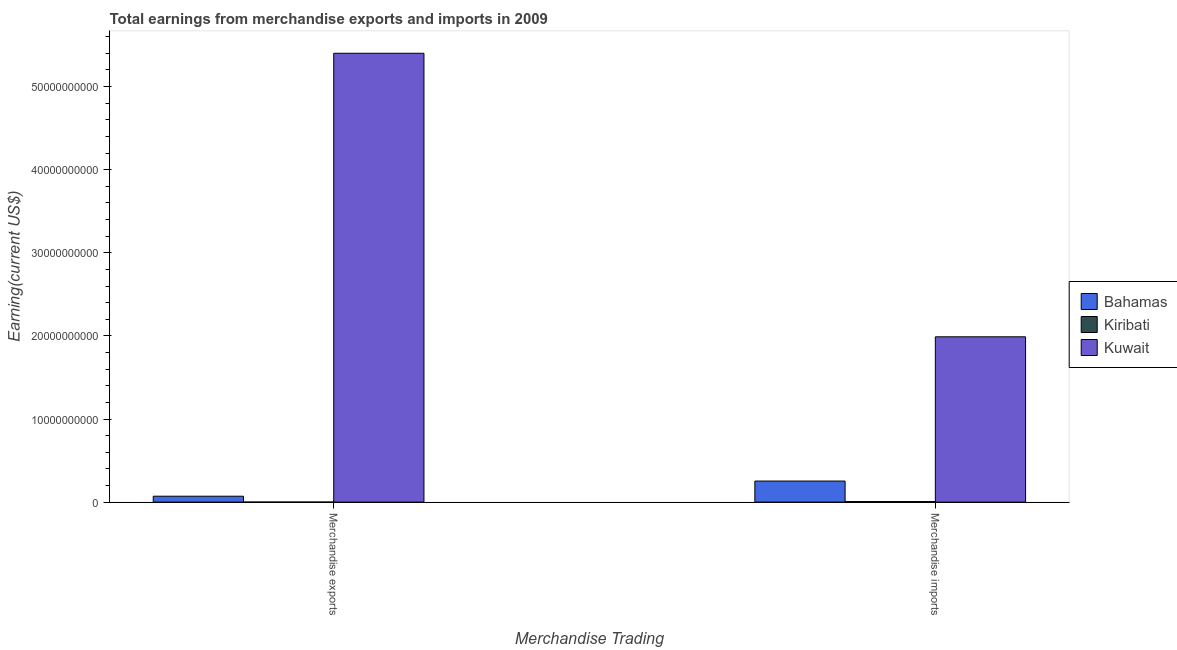How many groups of bars are there?
Give a very brief answer. 2. Are the number of bars on each tick of the X-axis equal?
Offer a terse response. Yes. How many bars are there on the 1st tick from the left?
Make the answer very short. 3. What is the earnings from merchandise exports in Kiribati?
Your answer should be compact. 6.28e+06. Across all countries, what is the maximum earnings from merchandise exports?
Offer a very short reply. 5.40e+1. Across all countries, what is the minimum earnings from merchandise exports?
Offer a terse response. 6.28e+06. In which country was the earnings from merchandise imports maximum?
Your answer should be compact. Kuwait. In which country was the earnings from merchandise exports minimum?
Keep it short and to the point. Kiribati. What is the total earnings from merchandise imports in the graph?
Your answer should be very brief. 2.25e+1. What is the difference between the earnings from merchandise exports in Kiribati and that in Kuwait?
Offer a very short reply. -5.40e+1. What is the difference between the earnings from merchandise imports in Kuwait and the earnings from merchandise exports in Bahamas?
Give a very brief answer. 1.92e+1. What is the average earnings from merchandise imports per country?
Give a very brief answer. 7.50e+09. What is the difference between the earnings from merchandise imports and earnings from merchandise exports in Bahamas?
Make the answer very short. 1.82e+09. What is the ratio of the earnings from merchandise imports in Kuwait to that in Kiribati?
Provide a short and direct response. 296.87. What does the 2nd bar from the left in Merchandise imports represents?
Ensure brevity in your answer.  Kiribati. What does the 3rd bar from the right in Merchandise exports represents?
Offer a very short reply. Bahamas. How many countries are there in the graph?
Your response must be concise. 3. Are the values on the major ticks of Y-axis written in scientific E-notation?
Give a very brief answer. No. Does the graph contain any zero values?
Provide a succinct answer. No. Does the graph contain grids?
Offer a terse response. No. How are the legend labels stacked?
Keep it short and to the point. Vertical. What is the title of the graph?
Make the answer very short. Total earnings from merchandise exports and imports in 2009. What is the label or title of the X-axis?
Your answer should be very brief. Merchandise Trading. What is the label or title of the Y-axis?
Make the answer very short. Earning(current US$). What is the Earning(current US$) in Bahamas in Merchandise exports?
Ensure brevity in your answer.  7.11e+08. What is the Earning(current US$) of Kiribati in Merchandise exports?
Provide a short and direct response. 6.28e+06. What is the Earning(current US$) in Kuwait in Merchandise exports?
Your answer should be compact. 5.40e+1. What is the Earning(current US$) in Bahamas in Merchandise imports?
Your response must be concise. 2.54e+09. What is the Earning(current US$) of Kiribati in Merchandise imports?
Your answer should be compact. 6.70e+07. What is the Earning(current US$) in Kuwait in Merchandise imports?
Make the answer very short. 1.99e+1. Across all Merchandise Trading, what is the maximum Earning(current US$) of Bahamas?
Make the answer very short. 2.54e+09. Across all Merchandise Trading, what is the maximum Earning(current US$) of Kiribati?
Provide a succinct answer. 6.70e+07. Across all Merchandise Trading, what is the maximum Earning(current US$) of Kuwait?
Your answer should be very brief. 5.40e+1. Across all Merchandise Trading, what is the minimum Earning(current US$) of Bahamas?
Your answer should be compact. 7.11e+08. Across all Merchandise Trading, what is the minimum Earning(current US$) in Kiribati?
Your response must be concise. 6.28e+06. Across all Merchandise Trading, what is the minimum Earning(current US$) in Kuwait?
Provide a short and direct response. 1.99e+1. What is the total Earning(current US$) of Bahamas in the graph?
Your answer should be very brief. 3.25e+09. What is the total Earning(current US$) in Kiribati in the graph?
Ensure brevity in your answer.  7.33e+07. What is the total Earning(current US$) of Kuwait in the graph?
Offer a very short reply. 7.39e+1. What is the difference between the Earning(current US$) in Bahamas in Merchandise exports and that in Merchandise imports?
Ensure brevity in your answer.  -1.82e+09. What is the difference between the Earning(current US$) of Kiribati in Merchandise exports and that in Merchandise imports?
Your answer should be compact. -6.07e+07. What is the difference between the Earning(current US$) in Kuwait in Merchandise exports and that in Merchandise imports?
Your answer should be compact. 3.41e+1. What is the difference between the Earning(current US$) in Bahamas in Merchandise exports and the Earning(current US$) in Kiribati in Merchandise imports?
Provide a short and direct response. 6.44e+08. What is the difference between the Earning(current US$) of Bahamas in Merchandise exports and the Earning(current US$) of Kuwait in Merchandise imports?
Offer a terse response. -1.92e+1. What is the difference between the Earning(current US$) of Kiribati in Merchandise exports and the Earning(current US$) of Kuwait in Merchandise imports?
Make the answer very short. -1.99e+1. What is the average Earning(current US$) of Bahamas per Merchandise Trading?
Offer a terse response. 1.62e+09. What is the average Earning(current US$) of Kiribati per Merchandise Trading?
Give a very brief answer. 3.66e+07. What is the average Earning(current US$) of Kuwait per Merchandise Trading?
Give a very brief answer. 3.70e+1. What is the difference between the Earning(current US$) of Bahamas and Earning(current US$) of Kiribati in Merchandise exports?
Give a very brief answer. 7.04e+08. What is the difference between the Earning(current US$) in Bahamas and Earning(current US$) in Kuwait in Merchandise exports?
Offer a very short reply. -5.33e+1. What is the difference between the Earning(current US$) in Kiribati and Earning(current US$) in Kuwait in Merchandise exports?
Your response must be concise. -5.40e+1. What is the difference between the Earning(current US$) of Bahamas and Earning(current US$) of Kiribati in Merchandise imports?
Your response must be concise. 2.47e+09. What is the difference between the Earning(current US$) in Bahamas and Earning(current US$) in Kuwait in Merchandise imports?
Provide a short and direct response. -1.74e+1. What is the difference between the Earning(current US$) in Kiribati and Earning(current US$) in Kuwait in Merchandise imports?
Provide a succinct answer. -1.98e+1. What is the ratio of the Earning(current US$) of Bahamas in Merchandise exports to that in Merchandise imports?
Give a very brief answer. 0.28. What is the ratio of the Earning(current US$) of Kiribati in Merchandise exports to that in Merchandise imports?
Provide a short and direct response. 0.09. What is the ratio of the Earning(current US$) in Kuwait in Merchandise exports to that in Merchandise imports?
Make the answer very short. 2.72. What is the difference between the highest and the second highest Earning(current US$) in Bahamas?
Your answer should be very brief. 1.82e+09. What is the difference between the highest and the second highest Earning(current US$) of Kiribati?
Provide a short and direct response. 6.07e+07. What is the difference between the highest and the second highest Earning(current US$) of Kuwait?
Your answer should be very brief. 3.41e+1. What is the difference between the highest and the lowest Earning(current US$) of Bahamas?
Keep it short and to the point. 1.82e+09. What is the difference between the highest and the lowest Earning(current US$) in Kiribati?
Your answer should be very brief. 6.07e+07. What is the difference between the highest and the lowest Earning(current US$) of Kuwait?
Give a very brief answer. 3.41e+1. 